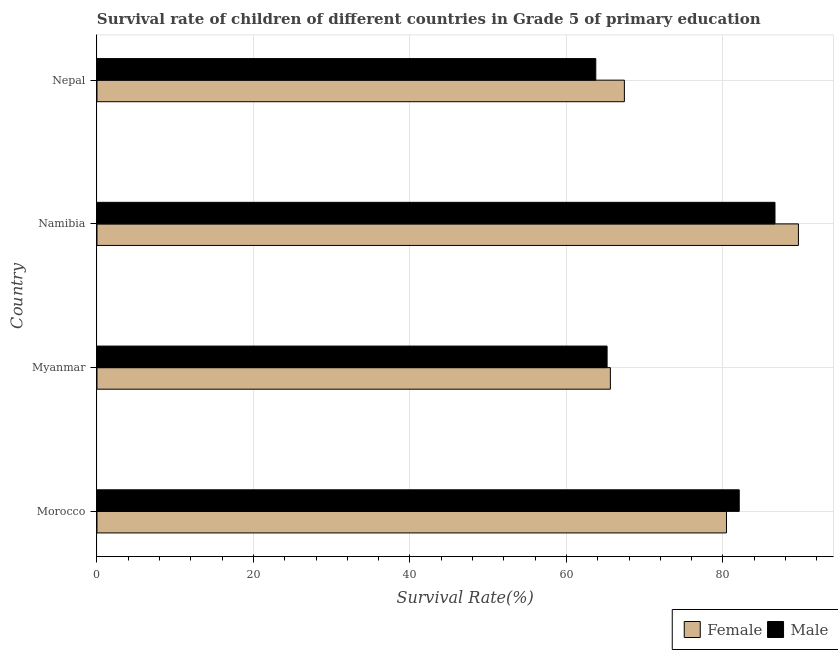How many different coloured bars are there?
Provide a short and direct response. 2. What is the label of the 3rd group of bars from the top?
Provide a succinct answer. Myanmar. What is the survival rate of male students in primary education in Namibia?
Give a very brief answer. 86.65. Across all countries, what is the maximum survival rate of male students in primary education?
Provide a short and direct response. 86.65. Across all countries, what is the minimum survival rate of female students in primary education?
Offer a terse response. 65.61. In which country was the survival rate of female students in primary education maximum?
Your answer should be compact. Namibia. In which country was the survival rate of female students in primary education minimum?
Make the answer very short. Myanmar. What is the total survival rate of male students in primary education in the graph?
Provide a short and direct response. 297.68. What is the difference between the survival rate of female students in primary education in Myanmar and that in Nepal?
Your answer should be very brief. -1.79. What is the difference between the survival rate of male students in primary education in Namibia and the survival rate of female students in primary education in Myanmar?
Provide a succinct answer. 21.04. What is the average survival rate of female students in primary education per country?
Provide a succinct answer. 75.78. What is the difference between the survival rate of male students in primary education and survival rate of female students in primary education in Namibia?
Your answer should be very brief. -3. What is the ratio of the survival rate of male students in primary education in Namibia to that in Nepal?
Provide a succinct answer. 1.36. Is the difference between the survival rate of male students in primary education in Myanmar and Namibia greater than the difference between the survival rate of female students in primary education in Myanmar and Namibia?
Ensure brevity in your answer.  Yes. What is the difference between the highest and the second highest survival rate of female students in primary education?
Offer a very short reply. 9.2. What is the difference between the highest and the lowest survival rate of female students in primary education?
Provide a short and direct response. 24.03. What does the 2nd bar from the top in Nepal represents?
Your answer should be compact. Female. How many bars are there?
Offer a terse response. 8. How many countries are there in the graph?
Provide a short and direct response. 4. What is the difference between two consecutive major ticks on the X-axis?
Make the answer very short. 20. Are the values on the major ticks of X-axis written in scientific E-notation?
Give a very brief answer. No. Does the graph contain any zero values?
Your answer should be very brief. No. Does the graph contain grids?
Ensure brevity in your answer.  Yes. How many legend labels are there?
Offer a terse response. 2. What is the title of the graph?
Your answer should be very brief. Survival rate of children of different countries in Grade 5 of primary education. Does "Female population" appear as one of the legend labels in the graph?
Provide a short and direct response. No. What is the label or title of the X-axis?
Keep it short and to the point. Survival Rate(%). What is the Survival Rate(%) of Female in Morocco?
Your answer should be very brief. 80.45. What is the Survival Rate(%) in Male in Morocco?
Your response must be concise. 82.08. What is the Survival Rate(%) of Female in Myanmar?
Provide a succinct answer. 65.61. What is the Survival Rate(%) in Male in Myanmar?
Your answer should be compact. 65.2. What is the Survival Rate(%) in Female in Namibia?
Offer a terse response. 89.65. What is the Survival Rate(%) of Male in Namibia?
Offer a terse response. 86.65. What is the Survival Rate(%) in Female in Nepal?
Ensure brevity in your answer.  67.41. What is the Survival Rate(%) in Male in Nepal?
Provide a short and direct response. 63.75. Across all countries, what is the maximum Survival Rate(%) of Female?
Offer a terse response. 89.65. Across all countries, what is the maximum Survival Rate(%) in Male?
Your response must be concise. 86.65. Across all countries, what is the minimum Survival Rate(%) of Female?
Ensure brevity in your answer.  65.61. Across all countries, what is the minimum Survival Rate(%) in Male?
Offer a very short reply. 63.75. What is the total Survival Rate(%) of Female in the graph?
Your answer should be very brief. 303.12. What is the total Survival Rate(%) in Male in the graph?
Ensure brevity in your answer.  297.68. What is the difference between the Survival Rate(%) in Female in Morocco and that in Myanmar?
Your response must be concise. 14.84. What is the difference between the Survival Rate(%) in Male in Morocco and that in Myanmar?
Keep it short and to the point. 16.89. What is the difference between the Survival Rate(%) of Female in Morocco and that in Namibia?
Your answer should be very brief. -9.2. What is the difference between the Survival Rate(%) of Male in Morocco and that in Namibia?
Provide a succinct answer. -4.57. What is the difference between the Survival Rate(%) of Female in Morocco and that in Nepal?
Your answer should be compact. 13.05. What is the difference between the Survival Rate(%) of Male in Morocco and that in Nepal?
Give a very brief answer. 18.33. What is the difference between the Survival Rate(%) of Female in Myanmar and that in Namibia?
Offer a terse response. -24.03. What is the difference between the Survival Rate(%) of Male in Myanmar and that in Namibia?
Ensure brevity in your answer.  -21.46. What is the difference between the Survival Rate(%) of Female in Myanmar and that in Nepal?
Give a very brief answer. -1.79. What is the difference between the Survival Rate(%) of Male in Myanmar and that in Nepal?
Your answer should be very brief. 1.45. What is the difference between the Survival Rate(%) of Female in Namibia and that in Nepal?
Ensure brevity in your answer.  22.24. What is the difference between the Survival Rate(%) in Male in Namibia and that in Nepal?
Make the answer very short. 22.9. What is the difference between the Survival Rate(%) in Female in Morocco and the Survival Rate(%) in Male in Myanmar?
Offer a terse response. 15.26. What is the difference between the Survival Rate(%) in Female in Morocco and the Survival Rate(%) in Male in Namibia?
Your response must be concise. -6.2. What is the difference between the Survival Rate(%) of Female in Morocco and the Survival Rate(%) of Male in Nepal?
Give a very brief answer. 16.7. What is the difference between the Survival Rate(%) in Female in Myanmar and the Survival Rate(%) in Male in Namibia?
Keep it short and to the point. -21.04. What is the difference between the Survival Rate(%) in Female in Myanmar and the Survival Rate(%) in Male in Nepal?
Give a very brief answer. 1.86. What is the difference between the Survival Rate(%) in Female in Namibia and the Survival Rate(%) in Male in Nepal?
Your answer should be very brief. 25.9. What is the average Survival Rate(%) of Female per country?
Make the answer very short. 75.78. What is the average Survival Rate(%) in Male per country?
Provide a succinct answer. 74.42. What is the difference between the Survival Rate(%) of Female and Survival Rate(%) of Male in Morocco?
Offer a terse response. -1.63. What is the difference between the Survival Rate(%) in Female and Survival Rate(%) in Male in Myanmar?
Make the answer very short. 0.42. What is the difference between the Survival Rate(%) in Female and Survival Rate(%) in Male in Namibia?
Provide a succinct answer. 2.99. What is the difference between the Survival Rate(%) of Female and Survival Rate(%) of Male in Nepal?
Your answer should be very brief. 3.66. What is the ratio of the Survival Rate(%) of Female in Morocco to that in Myanmar?
Keep it short and to the point. 1.23. What is the ratio of the Survival Rate(%) in Male in Morocco to that in Myanmar?
Ensure brevity in your answer.  1.26. What is the ratio of the Survival Rate(%) of Female in Morocco to that in Namibia?
Your answer should be very brief. 0.9. What is the ratio of the Survival Rate(%) in Male in Morocco to that in Namibia?
Your answer should be compact. 0.95. What is the ratio of the Survival Rate(%) in Female in Morocco to that in Nepal?
Your answer should be compact. 1.19. What is the ratio of the Survival Rate(%) in Male in Morocco to that in Nepal?
Give a very brief answer. 1.29. What is the ratio of the Survival Rate(%) in Female in Myanmar to that in Namibia?
Your answer should be compact. 0.73. What is the ratio of the Survival Rate(%) of Male in Myanmar to that in Namibia?
Your answer should be very brief. 0.75. What is the ratio of the Survival Rate(%) of Female in Myanmar to that in Nepal?
Keep it short and to the point. 0.97. What is the ratio of the Survival Rate(%) of Male in Myanmar to that in Nepal?
Offer a terse response. 1.02. What is the ratio of the Survival Rate(%) in Female in Namibia to that in Nepal?
Give a very brief answer. 1.33. What is the ratio of the Survival Rate(%) in Male in Namibia to that in Nepal?
Offer a very short reply. 1.36. What is the difference between the highest and the second highest Survival Rate(%) of Female?
Your response must be concise. 9.2. What is the difference between the highest and the second highest Survival Rate(%) of Male?
Your answer should be compact. 4.57. What is the difference between the highest and the lowest Survival Rate(%) of Female?
Give a very brief answer. 24.03. What is the difference between the highest and the lowest Survival Rate(%) in Male?
Your answer should be compact. 22.9. 